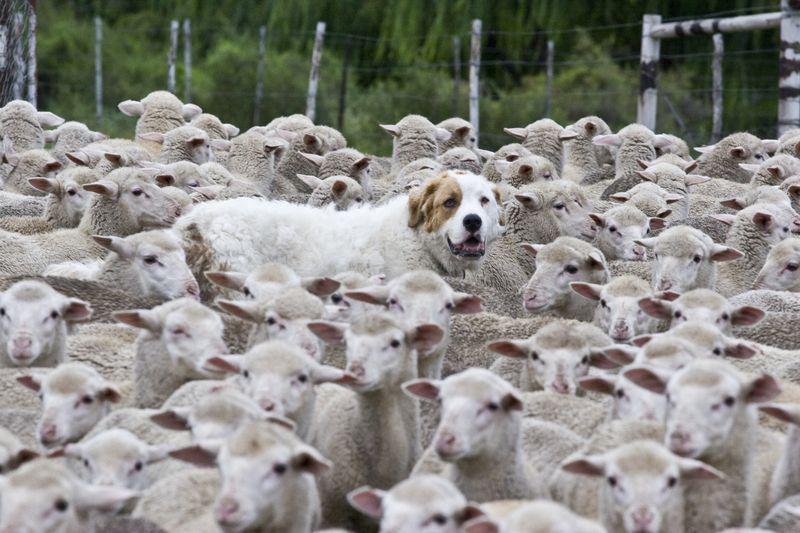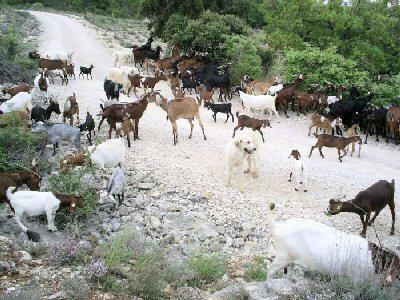The first image is the image on the left, the second image is the image on the right. Examine the images to the left and right. Is the description "An image features exactly two nearly identical dogs." accurate? Answer yes or no. No. The first image is the image on the left, the second image is the image on the right. Assess this claim about the two images: "There is a dog standing next to a fence.". Correct or not? Answer yes or no. No. 